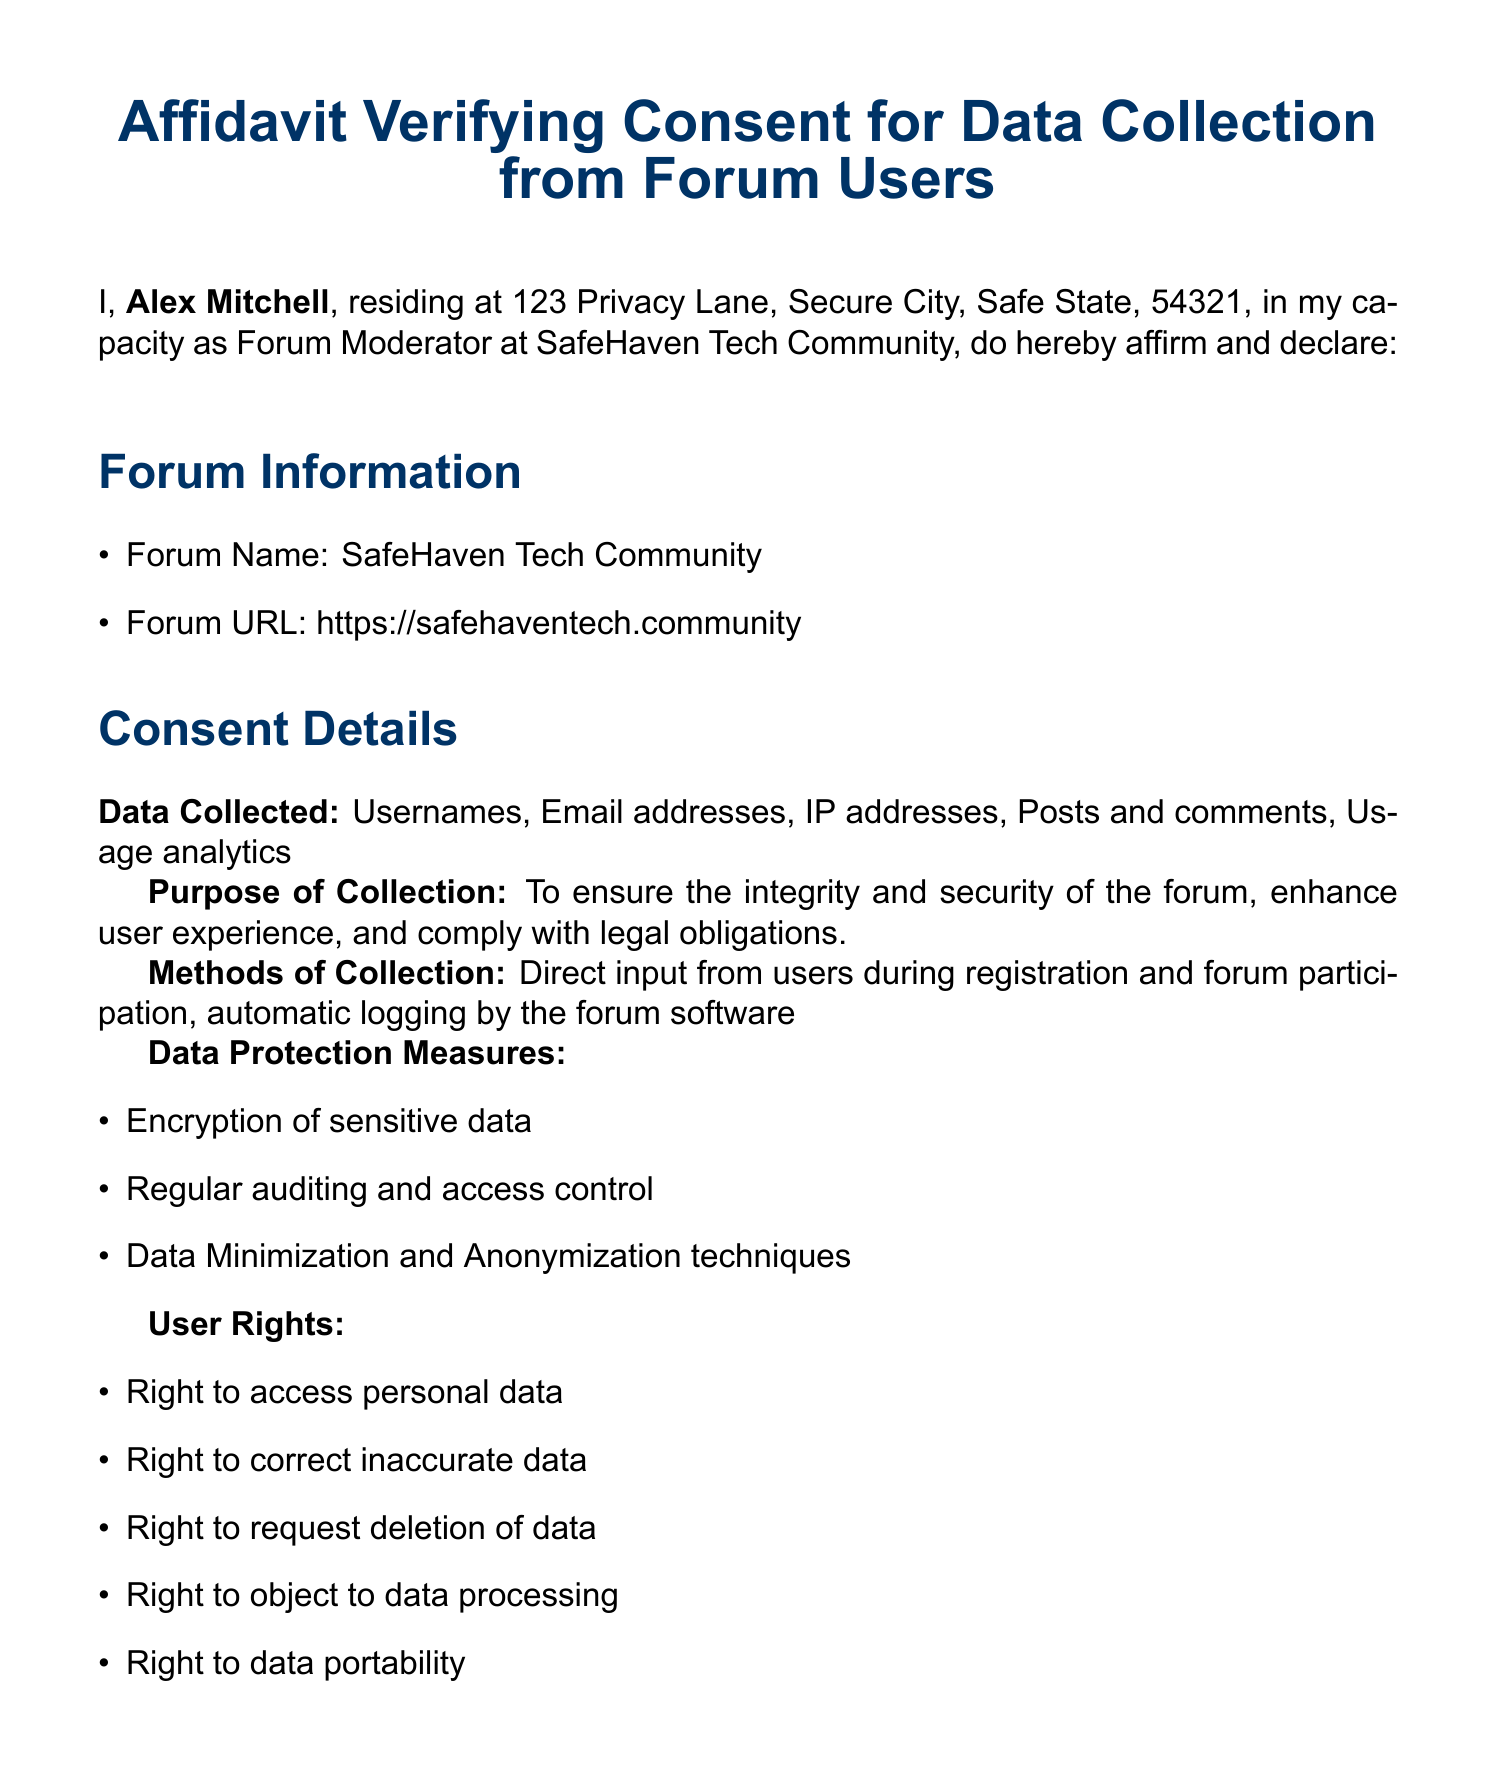What is the name of the forum? The name of the forum is explicitly stated in the document under the Forum Information section.
Answer: SafeHaven Tech Community Who is the affiant? The affiant is the person who signs the affidavit, and their name is mentioned at the beginning of the document.
Answer: Alex Mitchell What rights do users have? The rights of users are listed in the User Rights section of the document.
Answer: Right to access personal data What is the purpose of data collection? The purpose of data collection is outlined in the Consent Details section and specifies the intentions behind it.
Answer: To ensure the integrity and security of the forum What method is used to obtain consent? The method for obtaining consent is detailed in the Consent Obtained section and describes how users provide their agreement.
Answer: Explicit consent obtained during user registration When was the affidavit signed? The date of signing is noted at the end of the document, indicating when the affidavit was completed.
Answer: Not specified in the document Who notarized the affidavit? The document specifies the notary public who witnessed the signing of the affidavit.
Answer: Morgan Adams What kind of data is collected? The types of data collected are clearly listed in the Consent Details section of the document.
Answer: Usernames, Email addresses, IP addresses, Posts and comments, Usage analytics 